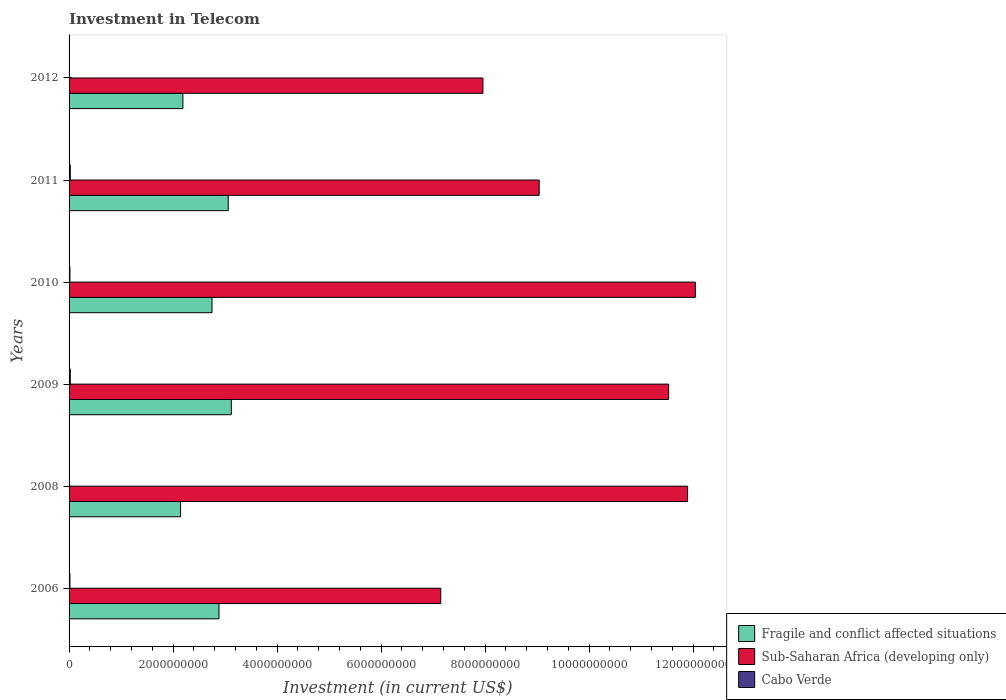How many bars are there on the 1st tick from the top?
Your answer should be compact. 3. In how many cases, is the number of bars for a given year not equal to the number of legend labels?
Ensure brevity in your answer.  0. What is the amount invested in telecom in Fragile and conflict affected situations in 2009?
Provide a short and direct response. 3.12e+09. Across all years, what is the maximum amount invested in telecom in Sub-Saharan Africa (developing only)?
Give a very brief answer. 1.20e+1. Across all years, what is the minimum amount invested in telecom in Sub-Saharan Africa (developing only)?
Ensure brevity in your answer.  7.15e+09. In which year was the amount invested in telecom in Sub-Saharan Africa (developing only) maximum?
Provide a short and direct response. 2010. In which year was the amount invested in telecom in Cabo Verde minimum?
Your answer should be very brief. 2008. What is the total amount invested in telecom in Cabo Verde in the graph?
Provide a short and direct response. 8.82e+07. What is the difference between the amount invested in telecom in Fragile and conflict affected situations in 2006 and that in 2012?
Your response must be concise. 6.94e+08. What is the difference between the amount invested in telecom in Sub-Saharan Africa (developing only) in 2011 and the amount invested in telecom in Fragile and conflict affected situations in 2008?
Provide a succinct answer. 6.90e+09. What is the average amount invested in telecom in Cabo Verde per year?
Provide a short and direct response. 1.47e+07. In the year 2010, what is the difference between the amount invested in telecom in Cabo Verde and amount invested in telecom in Sub-Saharan Africa (developing only)?
Ensure brevity in your answer.  -1.20e+1. In how many years, is the amount invested in telecom in Sub-Saharan Africa (developing only) greater than 11600000000 US$?
Provide a short and direct response. 2. What is the ratio of the amount invested in telecom in Sub-Saharan Africa (developing only) in 2010 to that in 2012?
Keep it short and to the point. 1.51. Is the amount invested in telecom in Cabo Verde in 2011 less than that in 2012?
Your response must be concise. No. What is the difference between the highest and the lowest amount invested in telecom in Cabo Verde?
Offer a terse response. 1.85e+07. In how many years, is the amount invested in telecom in Cabo Verde greater than the average amount invested in telecom in Cabo Verde taken over all years?
Your answer should be very brief. 4. Is the sum of the amount invested in telecom in Cabo Verde in 2006 and 2011 greater than the maximum amount invested in telecom in Sub-Saharan Africa (developing only) across all years?
Your response must be concise. No. What does the 2nd bar from the top in 2010 represents?
Make the answer very short. Sub-Saharan Africa (developing only). What does the 3rd bar from the bottom in 2006 represents?
Your response must be concise. Cabo Verde. How many bars are there?
Your answer should be very brief. 18. Are the values on the major ticks of X-axis written in scientific E-notation?
Give a very brief answer. No. Does the graph contain any zero values?
Give a very brief answer. No. Does the graph contain grids?
Offer a very short reply. No. Where does the legend appear in the graph?
Keep it short and to the point. Bottom right. How are the legend labels stacked?
Offer a terse response. Vertical. What is the title of the graph?
Keep it short and to the point. Investment in Telecom. Does "World" appear as one of the legend labels in the graph?
Offer a very short reply. No. What is the label or title of the X-axis?
Offer a terse response. Investment (in current US$). What is the label or title of the Y-axis?
Offer a very short reply. Years. What is the Investment (in current US$) of Fragile and conflict affected situations in 2006?
Offer a very short reply. 2.88e+09. What is the Investment (in current US$) in Sub-Saharan Africa (developing only) in 2006?
Give a very brief answer. 7.15e+09. What is the Investment (in current US$) in Cabo Verde in 2006?
Provide a succinct answer. 1.60e+07. What is the Investment (in current US$) of Fragile and conflict affected situations in 2008?
Make the answer very short. 2.14e+09. What is the Investment (in current US$) of Sub-Saharan Africa (developing only) in 2008?
Offer a very short reply. 1.19e+1. What is the Investment (in current US$) in Cabo Verde in 2008?
Make the answer very short. 4.70e+06. What is the Investment (in current US$) in Fragile and conflict affected situations in 2009?
Ensure brevity in your answer.  3.12e+09. What is the Investment (in current US$) of Sub-Saharan Africa (developing only) in 2009?
Your response must be concise. 1.15e+1. What is the Investment (in current US$) in Cabo Verde in 2009?
Give a very brief answer. 2.30e+07. What is the Investment (in current US$) in Fragile and conflict affected situations in 2010?
Your response must be concise. 2.75e+09. What is the Investment (in current US$) of Sub-Saharan Africa (developing only) in 2010?
Your answer should be very brief. 1.20e+1. What is the Investment (in current US$) of Cabo Verde in 2010?
Your answer should be very brief. 1.60e+07. What is the Investment (in current US$) in Fragile and conflict affected situations in 2011?
Your answer should be compact. 3.06e+09. What is the Investment (in current US$) of Sub-Saharan Africa (developing only) in 2011?
Your answer should be very brief. 9.04e+09. What is the Investment (in current US$) of Cabo Verde in 2011?
Provide a short and direct response. 2.32e+07. What is the Investment (in current US$) in Fragile and conflict affected situations in 2012?
Your answer should be very brief. 2.19e+09. What is the Investment (in current US$) in Sub-Saharan Africa (developing only) in 2012?
Provide a succinct answer. 7.96e+09. What is the Investment (in current US$) in Cabo Verde in 2012?
Keep it short and to the point. 5.30e+06. Across all years, what is the maximum Investment (in current US$) in Fragile and conflict affected situations?
Keep it short and to the point. 3.12e+09. Across all years, what is the maximum Investment (in current US$) of Sub-Saharan Africa (developing only)?
Your answer should be very brief. 1.20e+1. Across all years, what is the maximum Investment (in current US$) of Cabo Verde?
Provide a succinct answer. 2.32e+07. Across all years, what is the minimum Investment (in current US$) in Fragile and conflict affected situations?
Your answer should be compact. 2.14e+09. Across all years, what is the minimum Investment (in current US$) in Sub-Saharan Africa (developing only)?
Give a very brief answer. 7.15e+09. Across all years, what is the minimum Investment (in current US$) in Cabo Verde?
Your answer should be very brief. 4.70e+06. What is the total Investment (in current US$) of Fragile and conflict affected situations in the graph?
Offer a terse response. 1.61e+1. What is the total Investment (in current US$) of Sub-Saharan Africa (developing only) in the graph?
Provide a short and direct response. 5.96e+1. What is the total Investment (in current US$) in Cabo Verde in the graph?
Your answer should be very brief. 8.82e+07. What is the difference between the Investment (in current US$) in Fragile and conflict affected situations in 2006 and that in 2008?
Offer a very short reply. 7.39e+08. What is the difference between the Investment (in current US$) of Sub-Saharan Africa (developing only) in 2006 and that in 2008?
Ensure brevity in your answer.  -4.75e+09. What is the difference between the Investment (in current US$) of Cabo Verde in 2006 and that in 2008?
Your answer should be very brief. 1.13e+07. What is the difference between the Investment (in current US$) of Fragile and conflict affected situations in 2006 and that in 2009?
Your response must be concise. -2.37e+08. What is the difference between the Investment (in current US$) of Sub-Saharan Africa (developing only) in 2006 and that in 2009?
Your answer should be very brief. -4.38e+09. What is the difference between the Investment (in current US$) in Cabo Verde in 2006 and that in 2009?
Provide a short and direct response. -7.00e+06. What is the difference between the Investment (in current US$) of Fragile and conflict affected situations in 2006 and that in 2010?
Provide a short and direct response. 1.34e+08. What is the difference between the Investment (in current US$) in Sub-Saharan Africa (developing only) in 2006 and that in 2010?
Provide a short and direct response. -4.90e+09. What is the difference between the Investment (in current US$) in Cabo Verde in 2006 and that in 2010?
Your answer should be very brief. 0. What is the difference between the Investment (in current US$) in Fragile and conflict affected situations in 2006 and that in 2011?
Provide a succinct answer. -1.77e+08. What is the difference between the Investment (in current US$) in Sub-Saharan Africa (developing only) in 2006 and that in 2011?
Provide a succinct answer. -1.89e+09. What is the difference between the Investment (in current US$) in Cabo Verde in 2006 and that in 2011?
Your answer should be compact. -7.20e+06. What is the difference between the Investment (in current US$) of Fragile and conflict affected situations in 2006 and that in 2012?
Offer a very short reply. 6.94e+08. What is the difference between the Investment (in current US$) in Sub-Saharan Africa (developing only) in 2006 and that in 2012?
Provide a succinct answer. -8.11e+08. What is the difference between the Investment (in current US$) of Cabo Verde in 2006 and that in 2012?
Give a very brief answer. 1.07e+07. What is the difference between the Investment (in current US$) of Fragile and conflict affected situations in 2008 and that in 2009?
Keep it short and to the point. -9.76e+08. What is the difference between the Investment (in current US$) in Sub-Saharan Africa (developing only) in 2008 and that in 2009?
Ensure brevity in your answer.  3.64e+08. What is the difference between the Investment (in current US$) in Cabo Verde in 2008 and that in 2009?
Your answer should be very brief. -1.83e+07. What is the difference between the Investment (in current US$) in Fragile and conflict affected situations in 2008 and that in 2010?
Offer a very short reply. -6.05e+08. What is the difference between the Investment (in current US$) of Sub-Saharan Africa (developing only) in 2008 and that in 2010?
Your answer should be compact. -1.49e+08. What is the difference between the Investment (in current US$) in Cabo Verde in 2008 and that in 2010?
Your answer should be very brief. -1.13e+07. What is the difference between the Investment (in current US$) of Fragile and conflict affected situations in 2008 and that in 2011?
Your answer should be very brief. -9.16e+08. What is the difference between the Investment (in current US$) of Sub-Saharan Africa (developing only) in 2008 and that in 2011?
Ensure brevity in your answer.  2.85e+09. What is the difference between the Investment (in current US$) of Cabo Verde in 2008 and that in 2011?
Ensure brevity in your answer.  -1.85e+07. What is the difference between the Investment (in current US$) in Fragile and conflict affected situations in 2008 and that in 2012?
Your answer should be compact. -4.48e+07. What is the difference between the Investment (in current US$) of Sub-Saharan Africa (developing only) in 2008 and that in 2012?
Your response must be concise. 3.93e+09. What is the difference between the Investment (in current US$) in Cabo Verde in 2008 and that in 2012?
Keep it short and to the point. -6.00e+05. What is the difference between the Investment (in current US$) of Fragile and conflict affected situations in 2009 and that in 2010?
Provide a short and direct response. 3.71e+08. What is the difference between the Investment (in current US$) in Sub-Saharan Africa (developing only) in 2009 and that in 2010?
Give a very brief answer. -5.13e+08. What is the difference between the Investment (in current US$) in Cabo Verde in 2009 and that in 2010?
Keep it short and to the point. 7.00e+06. What is the difference between the Investment (in current US$) in Fragile and conflict affected situations in 2009 and that in 2011?
Your answer should be very brief. 5.91e+07. What is the difference between the Investment (in current US$) in Sub-Saharan Africa (developing only) in 2009 and that in 2011?
Give a very brief answer. 2.49e+09. What is the difference between the Investment (in current US$) in Fragile and conflict affected situations in 2009 and that in 2012?
Ensure brevity in your answer.  9.31e+08. What is the difference between the Investment (in current US$) in Sub-Saharan Africa (developing only) in 2009 and that in 2012?
Provide a succinct answer. 3.57e+09. What is the difference between the Investment (in current US$) of Cabo Verde in 2009 and that in 2012?
Provide a short and direct response. 1.77e+07. What is the difference between the Investment (in current US$) of Fragile and conflict affected situations in 2010 and that in 2011?
Provide a succinct answer. -3.12e+08. What is the difference between the Investment (in current US$) in Sub-Saharan Africa (developing only) in 2010 and that in 2011?
Make the answer very short. 3.00e+09. What is the difference between the Investment (in current US$) of Cabo Verde in 2010 and that in 2011?
Make the answer very short. -7.20e+06. What is the difference between the Investment (in current US$) of Fragile and conflict affected situations in 2010 and that in 2012?
Make the answer very short. 5.60e+08. What is the difference between the Investment (in current US$) in Sub-Saharan Africa (developing only) in 2010 and that in 2012?
Keep it short and to the point. 4.08e+09. What is the difference between the Investment (in current US$) of Cabo Verde in 2010 and that in 2012?
Make the answer very short. 1.07e+07. What is the difference between the Investment (in current US$) of Fragile and conflict affected situations in 2011 and that in 2012?
Provide a short and direct response. 8.72e+08. What is the difference between the Investment (in current US$) of Sub-Saharan Africa (developing only) in 2011 and that in 2012?
Provide a succinct answer. 1.08e+09. What is the difference between the Investment (in current US$) of Cabo Verde in 2011 and that in 2012?
Your answer should be compact. 1.79e+07. What is the difference between the Investment (in current US$) in Fragile and conflict affected situations in 2006 and the Investment (in current US$) in Sub-Saharan Africa (developing only) in 2008?
Keep it short and to the point. -9.01e+09. What is the difference between the Investment (in current US$) in Fragile and conflict affected situations in 2006 and the Investment (in current US$) in Cabo Verde in 2008?
Your answer should be very brief. 2.88e+09. What is the difference between the Investment (in current US$) in Sub-Saharan Africa (developing only) in 2006 and the Investment (in current US$) in Cabo Verde in 2008?
Ensure brevity in your answer.  7.14e+09. What is the difference between the Investment (in current US$) in Fragile and conflict affected situations in 2006 and the Investment (in current US$) in Sub-Saharan Africa (developing only) in 2009?
Your answer should be very brief. -8.65e+09. What is the difference between the Investment (in current US$) in Fragile and conflict affected situations in 2006 and the Investment (in current US$) in Cabo Verde in 2009?
Your response must be concise. 2.86e+09. What is the difference between the Investment (in current US$) in Sub-Saharan Africa (developing only) in 2006 and the Investment (in current US$) in Cabo Verde in 2009?
Make the answer very short. 7.12e+09. What is the difference between the Investment (in current US$) in Fragile and conflict affected situations in 2006 and the Investment (in current US$) in Sub-Saharan Africa (developing only) in 2010?
Provide a succinct answer. -9.16e+09. What is the difference between the Investment (in current US$) in Fragile and conflict affected situations in 2006 and the Investment (in current US$) in Cabo Verde in 2010?
Provide a short and direct response. 2.87e+09. What is the difference between the Investment (in current US$) in Sub-Saharan Africa (developing only) in 2006 and the Investment (in current US$) in Cabo Verde in 2010?
Provide a short and direct response. 7.13e+09. What is the difference between the Investment (in current US$) of Fragile and conflict affected situations in 2006 and the Investment (in current US$) of Sub-Saharan Africa (developing only) in 2011?
Ensure brevity in your answer.  -6.16e+09. What is the difference between the Investment (in current US$) of Fragile and conflict affected situations in 2006 and the Investment (in current US$) of Cabo Verde in 2011?
Give a very brief answer. 2.86e+09. What is the difference between the Investment (in current US$) in Sub-Saharan Africa (developing only) in 2006 and the Investment (in current US$) in Cabo Verde in 2011?
Ensure brevity in your answer.  7.12e+09. What is the difference between the Investment (in current US$) in Fragile and conflict affected situations in 2006 and the Investment (in current US$) in Sub-Saharan Africa (developing only) in 2012?
Your response must be concise. -5.08e+09. What is the difference between the Investment (in current US$) of Fragile and conflict affected situations in 2006 and the Investment (in current US$) of Cabo Verde in 2012?
Provide a succinct answer. 2.88e+09. What is the difference between the Investment (in current US$) of Sub-Saharan Africa (developing only) in 2006 and the Investment (in current US$) of Cabo Verde in 2012?
Keep it short and to the point. 7.14e+09. What is the difference between the Investment (in current US$) of Fragile and conflict affected situations in 2008 and the Investment (in current US$) of Sub-Saharan Africa (developing only) in 2009?
Keep it short and to the point. -9.38e+09. What is the difference between the Investment (in current US$) in Fragile and conflict affected situations in 2008 and the Investment (in current US$) in Cabo Verde in 2009?
Offer a very short reply. 2.12e+09. What is the difference between the Investment (in current US$) in Sub-Saharan Africa (developing only) in 2008 and the Investment (in current US$) in Cabo Verde in 2009?
Provide a short and direct response. 1.19e+1. What is the difference between the Investment (in current US$) of Fragile and conflict affected situations in 2008 and the Investment (in current US$) of Sub-Saharan Africa (developing only) in 2010?
Your answer should be very brief. -9.90e+09. What is the difference between the Investment (in current US$) of Fragile and conflict affected situations in 2008 and the Investment (in current US$) of Cabo Verde in 2010?
Ensure brevity in your answer.  2.13e+09. What is the difference between the Investment (in current US$) in Sub-Saharan Africa (developing only) in 2008 and the Investment (in current US$) in Cabo Verde in 2010?
Provide a short and direct response. 1.19e+1. What is the difference between the Investment (in current US$) in Fragile and conflict affected situations in 2008 and the Investment (in current US$) in Sub-Saharan Africa (developing only) in 2011?
Your answer should be very brief. -6.90e+09. What is the difference between the Investment (in current US$) in Fragile and conflict affected situations in 2008 and the Investment (in current US$) in Cabo Verde in 2011?
Provide a short and direct response. 2.12e+09. What is the difference between the Investment (in current US$) of Sub-Saharan Africa (developing only) in 2008 and the Investment (in current US$) of Cabo Verde in 2011?
Offer a terse response. 1.19e+1. What is the difference between the Investment (in current US$) in Fragile and conflict affected situations in 2008 and the Investment (in current US$) in Sub-Saharan Africa (developing only) in 2012?
Your answer should be very brief. -5.81e+09. What is the difference between the Investment (in current US$) of Fragile and conflict affected situations in 2008 and the Investment (in current US$) of Cabo Verde in 2012?
Ensure brevity in your answer.  2.14e+09. What is the difference between the Investment (in current US$) of Sub-Saharan Africa (developing only) in 2008 and the Investment (in current US$) of Cabo Verde in 2012?
Your answer should be compact. 1.19e+1. What is the difference between the Investment (in current US$) in Fragile and conflict affected situations in 2009 and the Investment (in current US$) in Sub-Saharan Africa (developing only) in 2010?
Give a very brief answer. -8.92e+09. What is the difference between the Investment (in current US$) in Fragile and conflict affected situations in 2009 and the Investment (in current US$) in Cabo Verde in 2010?
Provide a succinct answer. 3.10e+09. What is the difference between the Investment (in current US$) in Sub-Saharan Africa (developing only) in 2009 and the Investment (in current US$) in Cabo Verde in 2010?
Give a very brief answer. 1.15e+1. What is the difference between the Investment (in current US$) of Fragile and conflict affected situations in 2009 and the Investment (in current US$) of Sub-Saharan Africa (developing only) in 2011?
Provide a succinct answer. -5.92e+09. What is the difference between the Investment (in current US$) in Fragile and conflict affected situations in 2009 and the Investment (in current US$) in Cabo Verde in 2011?
Your answer should be compact. 3.10e+09. What is the difference between the Investment (in current US$) in Sub-Saharan Africa (developing only) in 2009 and the Investment (in current US$) in Cabo Verde in 2011?
Give a very brief answer. 1.15e+1. What is the difference between the Investment (in current US$) in Fragile and conflict affected situations in 2009 and the Investment (in current US$) in Sub-Saharan Africa (developing only) in 2012?
Your answer should be compact. -4.84e+09. What is the difference between the Investment (in current US$) in Fragile and conflict affected situations in 2009 and the Investment (in current US$) in Cabo Verde in 2012?
Ensure brevity in your answer.  3.11e+09. What is the difference between the Investment (in current US$) of Sub-Saharan Africa (developing only) in 2009 and the Investment (in current US$) of Cabo Verde in 2012?
Offer a terse response. 1.15e+1. What is the difference between the Investment (in current US$) of Fragile and conflict affected situations in 2010 and the Investment (in current US$) of Sub-Saharan Africa (developing only) in 2011?
Offer a terse response. -6.29e+09. What is the difference between the Investment (in current US$) of Fragile and conflict affected situations in 2010 and the Investment (in current US$) of Cabo Verde in 2011?
Provide a short and direct response. 2.73e+09. What is the difference between the Investment (in current US$) in Sub-Saharan Africa (developing only) in 2010 and the Investment (in current US$) in Cabo Verde in 2011?
Provide a succinct answer. 1.20e+1. What is the difference between the Investment (in current US$) in Fragile and conflict affected situations in 2010 and the Investment (in current US$) in Sub-Saharan Africa (developing only) in 2012?
Your answer should be very brief. -5.21e+09. What is the difference between the Investment (in current US$) in Fragile and conflict affected situations in 2010 and the Investment (in current US$) in Cabo Verde in 2012?
Your answer should be very brief. 2.74e+09. What is the difference between the Investment (in current US$) in Sub-Saharan Africa (developing only) in 2010 and the Investment (in current US$) in Cabo Verde in 2012?
Provide a succinct answer. 1.20e+1. What is the difference between the Investment (in current US$) in Fragile and conflict affected situations in 2011 and the Investment (in current US$) in Sub-Saharan Africa (developing only) in 2012?
Offer a terse response. -4.90e+09. What is the difference between the Investment (in current US$) in Fragile and conflict affected situations in 2011 and the Investment (in current US$) in Cabo Verde in 2012?
Your response must be concise. 3.06e+09. What is the difference between the Investment (in current US$) in Sub-Saharan Africa (developing only) in 2011 and the Investment (in current US$) in Cabo Verde in 2012?
Make the answer very short. 9.03e+09. What is the average Investment (in current US$) of Fragile and conflict affected situations per year?
Provide a short and direct response. 2.69e+09. What is the average Investment (in current US$) of Sub-Saharan Africa (developing only) per year?
Your answer should be compact. 9.93e+09. What is the average Investment (in current US$) of Cabo Verde per year?
Your answer should be compact. 1.47e+07. In the year 2006, what is the difference between the Investment (in current US$) in Fragile and conflict affected situations and Investment (in current US$) in Sub-Saharan Africa (developing only)?
Offer a very short reply. -4.26e+09. In the year 2006, what is the difference between the Investment (in current US$) of Fragile and conflict affected situations and Investment (in current US$) of Cabo Verde?
Your response must be concise. 2.87e+09. In the year 2006, what is the difference between the Investment (in current US$) of Sub-Saharan Africa (developing only) and Investment (in current US$) of Cabo Verde?
Your response must be concise. 7.13e+09. In the year 2008, what is the difference between the Investment (in current US$) of Fragile and conflict affected situations and Investment (in current US$) of Sub-Saharan Africa (developing only)?
Make the answer very short. -9.75e+09. In the year 2008, what is the difference between the Investment (in current US$) of Fragile and conflict affected situations and Investment (in current US$) of Cabo Verde?
Offer a terse response. 2.14e+09. In the year 2008, what is the difference between the Investment (in current US$) in Sub-Saharan Africa (developing only) and Investment (in current US$) in Cabo Verde?
Offer a terse response. 1.19e+1. In the year 2009, what is the difference between the Investment (in current US$) of Fragile and conflict affected situations and Investment (in current US$) of Sub-Saharan Africa (developing only)?
Offer a terse response. -8.41e+09. In the year 2009, what is the difference between the Investment (in current US$) of Fragile and conflict affected situations and Investment (in current US$) of Cabo Verde?
Make the answer very short. 3.10e+09. In the year 2009, what is the difference between the Investment (in current US$) in Sub-Saharan Africa (developing only) and Investment (in current US$) in Cabo Verde?
Offer a very short reply. 1.15e+1. In the year 2010, what is the difference between the Investment (in current US$) in Fragile and conflict affected situations and Investment (in current US$) in Sub-Saharan Africa (developing only)?
Your answer should be compact. -9.29e+09. In the year 2010, what is the difference between the Investment (in current US$) of Fragile and conflict affected situations and Investment (in current US$) of Cabo Verde?
Offer a terse response. 2.73e+09. In the year 2010, what is the difference between the Investment (in current US$) in Sub-Saharan Africa (developing only) and Investment (in current US$) in Cabo Verde?
Your answer should be compact. 1.20e+1. In the year 2011, what is the difference between the Investment (in current US$) in Fragile and conflict affected situations and Investment (in current US$) in Sub-Saharan Africa (developing only)?
Offer a very short reply. -5.98e+09. In the year 2011, what is the difference between the Investment (in current US$) in Fragile and conflict affected situations and Investment (in current US$) in Cabo Verde?
Ensure brevity in your answer.  3.04e+09. In the year 2011, what is the difference between the Investment (in current US$) of Sub-Saharan Africa (developing only) and Investment (in current US$) of Cabo Verde?
Ensure brevity in your answer.  9.02e+09. In the year 2012, what is the difference between the Investment (in current US$) of Fragile and conflict affected situations and Investment (in current US$) of Sub-Saharan Africa (developing only)?
Ensure brevity in your answer.  -5.77e+09. In the year 2012, what is the difference between the Investment (in current US$) in Fragile and conflict affected situations and Investment (in current US$) in Cabo Verde?
Your answer should be compact. 2.18e+09. In the year 2012, what is the difference between the Investment (in current US$) of Sub-Saharan Africa (developing only) and Investment (in current US$) of Cabo Verde?
Your answer should be compact. 7.95e+09. What is the ratio of the Investment (in current US$) of Fragile and conflict affected situations in 2006 to that in 2008?
Make the answer very short. 1.34. What is the ratio of the Investment (in current US$) in Sub-Saharan Africa (developing only) in 2006 to that in 2008?
Give a very brief answer. 0.6. What is the ratio of the Investment (in current US$) in Cabo Verde in 2006 to that in 2008?
Provide a short and direct response. 3.4. What is the ratio of the Investment (in current US$) in Fragile and conflict affected situations in 2006 to that in 2009?
Make the answer very short. 0.92. What is the ratio of the Investment (in current US$) in Sub-Saharan Africa (developing only) in 2006 to that in 2009?
Ensure brevity in your answer.  0.62. What is the ratio of the Investment (in current US$) in Cabo Verde in 2006 to that in 2009?
Offer a terse response. 0.7. What is the ratio of the Investment (in current US$) of Fragile and conflict affected situations in 2006 to that in 2010?
Make the answer very short. 1.05. What is the ratio of the Investment (in current US$) of Sub-Saharan Africa (developing only) in 2006 to that in 2010?
Ensure brevity in your answer.  0.59. What is the ratio of the Investment (in current US$) in Fragile and conflict affected situations in 2006 to that in 2011?
Make the answer very short. 0.94. What is the ratio of the Investment (in current US$) in Sub-Saharan Africa (developing only) in 2006 to that in 2011?
Keep it short and to the point. 0.79. What is the ratio of the Investment (in current US$) in Cabo Verde in 2006 to that in 2011?
Ensure brevity in your answer.  0.69. What is the ratio of the Investment (in current US$) in Fragile and conflict affected situations in 2006 to that in 2012?
Make the answer very short. 1.32. What is the ratio of the Investment (in current US$) of Sub-Saharan Africa (developing only) in 2006 to that in 2012?
Provide a succinct answer. 0.9. What is the ratio of the Investment (in current US$) in Cabo Verde in 2006 to that in 2012?
Offer a terse response. 3.02. What is the ratio of the Investment (in current US$) of Fragile and conflict affected situations in 2008 to that in 2009?
Your answer should be very brief. 0.69. What is the ratio of the Investment (in current US$) of Sub-Saharan Africa (developing only) in 2008 to that in 2009?
Offer a very short reply. 1.03. What is the ratio of the Investment (in current US$) in Cabo Verde in 2008 to that in 2009?
Your answer should be very brief. 0.2. What is the ratio of the Investment (in current US$) of Fragile and conflict affected situations in 2008 to that in 2010?
Give a very brief answer. 0.78. What is the ratio of the Investment (in current US$) in Sub-Saharan Africa (developing only) in 2008 to that in 2010?
Offer a terse response. 0.99. What is the ratio of the Investment (in current US$) in Cabo Verde in 2008 to that in 2010?
Ensure brevity in your answer.  0.29. What is the ratio of the Investment (in current US$) of Fragile and conflict affected situations in 2008 to that in 2011?
Make the answer very short. 0.7. What is the ratio of the Investment (in current US$) in Sub-Saharan Africa (developing only) in 2008 to that in 2011?
Your answer should be very brief. 1.32. What is the ratio of the Investment (in current US$) of Cabo Verde in 2008 to that in 2011?
Provide a short and direct response. 0.2. What is the ratio of the Investment (in current US$) of Fragile and conflict affected situations in 2008 to that in 2012?
Your answer should be compact. 0.98. What is the ratio of the Investment (in current US$) in Sub-Saharan Africa (developing only) in 2008 to that in 2012?
Your answer should be compact. 1.49. What is the ratio of the Investment (in current US$) in Cabo Verde in 2008 to that in 2012?
Give a very brief answer. 0.89. What is the ratio of the Investment (in current US$) in Fragile and conflict affected situations in 2009 to that in 2010?
Your answer should be compact. 1.13. What is the ratio of the Investment (in current US$) in Sub-Saharan Africa (developing only) in 2009 to that in 2010?
Your answer should be very brief. 0.96. What is the ratio of the Investment (in current US$) in Cabo Verde in 2009 to that in 2010?
Make the answer very short. 1.44. What is the ratio of the Investment (in current US$) of Fragile and conflict affected situations in 2009 to that in 2011?
Provide a short and direct response. 1.02. What is the ratio of the Investment (in current US$) of Sub-Saharan Africa (developing only) in 2009 to that in 2011?
Keep it short and to the point. 1.28. What is the ratio of the Investment (in current US$) in Fragile and conflict affected situations in 2009 to that in 2012?
Offer a terse response. 1.43. What is the ratio of the Investment (in current US$) of Sub-Saharan Africa (developing only) in 2009 to that in 2012?
Your response must be concise. 1.45. What is the ratio of the Investment (in current US$) in Cabo Verde in 2009 to that in 2012?
Your response must be concise. 4.34. What is the ratio of the Investment (in current US$) in Fragile and conflict affected situations in 2010 to that in 2011?
Ensure brevity in your answer.  0.9. What is the ratio of the Investment (in current US$) of Sub-Saharan Africa (developing only) in 2010 to that in 2011?
Your answer should be compact. 1.33. What is the ratio of the Investment (in current US$) of Cabo Verde in 2010 to that in 2011?
Keep it short and to the point. 0.69. What is the ratio of the Investment (in current US$) in Fragile and conflict affected situations in 2010 to that in 2012?
Your answer should be compact. 1.26. What is the ratio of the Investment (in current US$) in Sub-Saharan Africa (developing only) in 2010 to that in 2012?
Ensure brevity in your answer.  1.51. What is the ratio of the Investment (in current US$) of Cabo Verde in 2010 to that in 2012?
Offer a very short reply. 3.02. What is the ratio of the Investment (in current US$) of Fragile and conflict affected situations in 2011 to that in 2012?
Provide a succinct answer. 1.4. What is the ratio of the Investment (in current US$) in Sub-Saharan Africa (developing only) in 2011 to that in 2012?
Provide a short and direct response. 1.14. What is the ratio of the Investment (in current US$) of Cabo Verde in 2011 to that in 2012?
Offer a very short reply. 4.38. What is the difference between the highest and the second highest Investment (in current US$) of Fragile and conflict affected situations?
Your answer should be very brief. 5.91e+07. What is the difference between the highest and the second highest Investment (in current US$) of Sub-Saharan Africa (developing only)?
Your answer should be compact. 1.49e+08. What is the difference between the highest and the lowest Investment (in current US$) in Fragile and conflict affected situations?
Your response must be concise. 9.76e+08. What is the difference between the highest and the lowest Investment (in current US$) of Sub-Saharan Africa (developing only)?
Your answer should be compact. 4.90e+09. What is the difference between the highest and the lowest Investment (in current US$) of Cabo Verde?
Keep it short and to the point. 1.85e+07. 